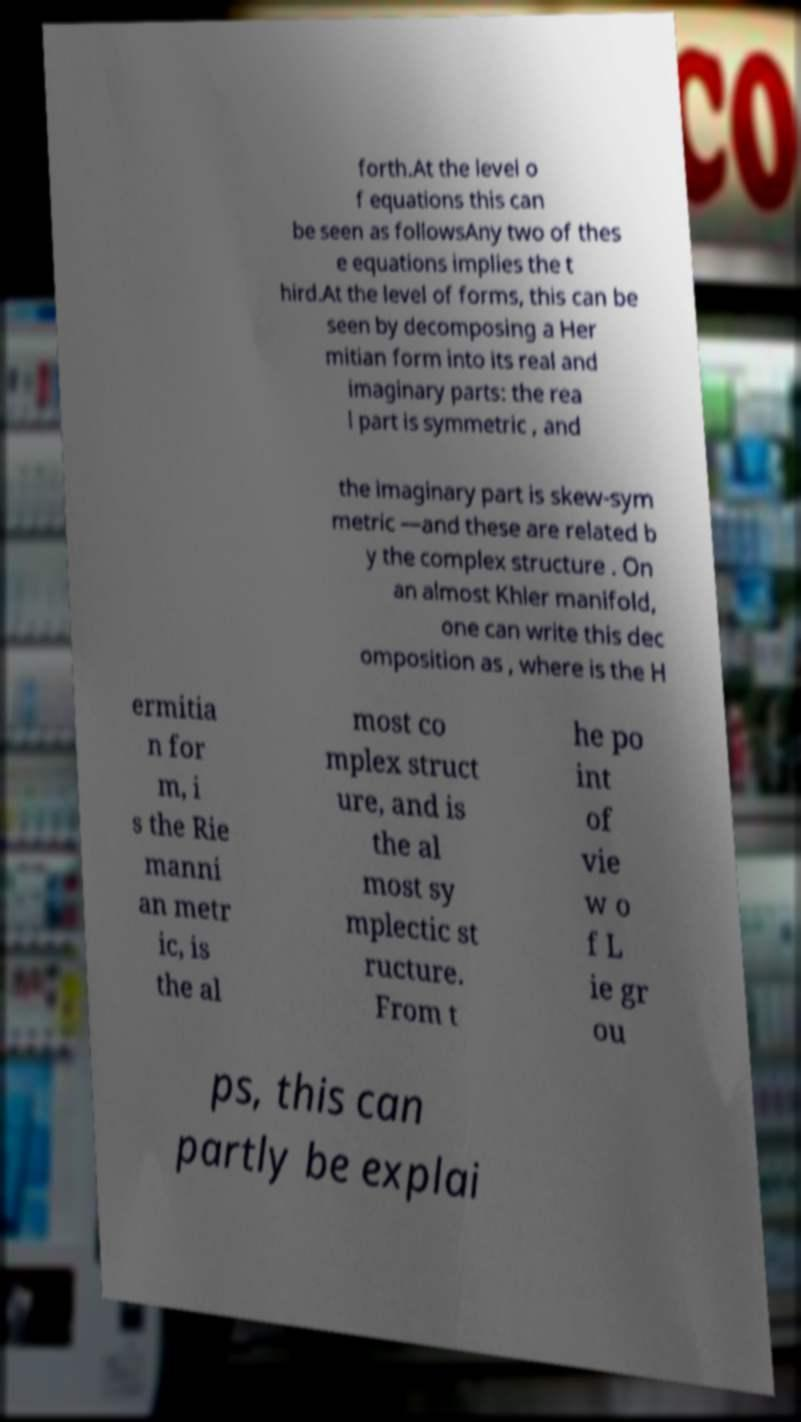For documentation purposes, I need the text within this image transcribed. Could you provide that? forth.At the level o f equations this can be seen as followsAny two of thes e equations implies the t hird.At the level of forms, this can be seen by decomposing a Her mitian form into its real and imaginary parts: the rea l part is symmetric , and the imaginary part is skew-sym metric —and these are related b y the complex structure . On an almost Khler manifold, one can write this dec omposition as , where is the H ermitia n for m, i s the Rie manni an metr ic, is the al most co mplex struct ure, and is the al most sy mplectic st ructure. From t he po int of vie w o f L ie gr ou ps, this can partly be explai 